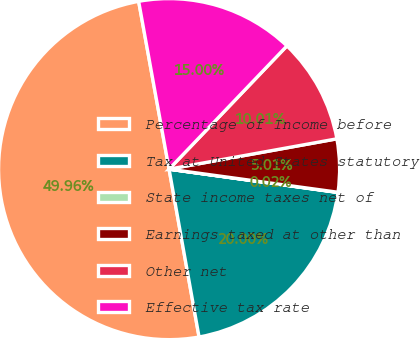Convert chart. <chart><loc_0><loc_0><loc_500><loc_500><pie_chart><fcel>Percentage of Income before<fcel>Tax at United States statutory<fcel>State income taxes net of<fcel>Earnings taxed at other than<fcel>Other net<fcel>Effective tax rate<nl><fcel>49.96%<fcel>20.0%<fcel>0.02%<fcel>5.01%<fcel>10.01%<fcel>15.0%<nl></chart> 